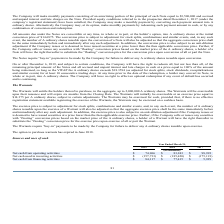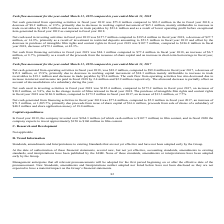From Eros International Plc's financial document, What is the  Net cash from operating activities for 2017, 2018 and 2019 respectively? The document contains multiple relevant values: $98,993, $83,243, $74,966 (in thousands). From the document: "ash from operating activities $ 74,966 $ 83,243 $ 98,993 Net cash from operating activities $ 74,966 $ 83,243 $ 98,993 Net cash from operating activit..." Also, What was the reason for decrease in net cash generated from operating activities in 2019? primarily due to decrease in working capital movement of $65.1 million, mainly attributable to increase in trade receivables by $88.5 million and increase in trade payables by $23.4 million and as a result of lower operating profit before exceptional item generated in fiscal year 2019 as compared to fiscal year 2018.. The document states: "al year 2018, a decrease of $8.2 million, or 9.9%, primarily due to decrease in working capital movement of $65.1 million, mainly attributable to incr..." Also, What was the net cash increase in financing activities? According to the financial document, $6.7 million. The relevant text states: "$77.4 million in fiscal year 2018, an increase of $6.7 million, or 8.7%, primarily as a result of the proceeds from the issuance of share capital and an increase..." Additionally, Which year(s) had a  Net cash from financing activities greater than $70,000 thousand? The document shows two values: 2018 and 2019. From the document: "2019 2018 2017 2019 2018 2017..." Also, can you calculate: What is the average annual Net cash used in investing activities for 2017-2019? To answer this question, I need to perform calculations using the financial data. The calculation is: -(157,733 + 185,420 + 175,191) / 3, which equals -172781.33 (in thousands). This is based on the information: "Net cash used in investing activities $ (157,733) $ (185,420) $ (175,191) n investing activities $ (157,733) $ (185,420) $ (175,191) cash used in investing activities $ (157,733) $ (185,420) $ (175,19..." The key data points involved are: 157,733, 175,191, 185,420. Also, can you calculate: What is the percentage increase / (decrease) in the net cash from financing activities from 2018 to 2019? To answer this question, I need to perform calculations using the financial data. The calculation is: 84,117 / 77,415 - 1, which equals 8.66 (percentage). This is based on the information: "Net cash from financing activities $ 84,117 $ 77,415 $ 5,929 Net cash from financing activities $ 84,117 $ 77,415 $ 5,929..." The key data points involved are: 77,415, 84,117. 